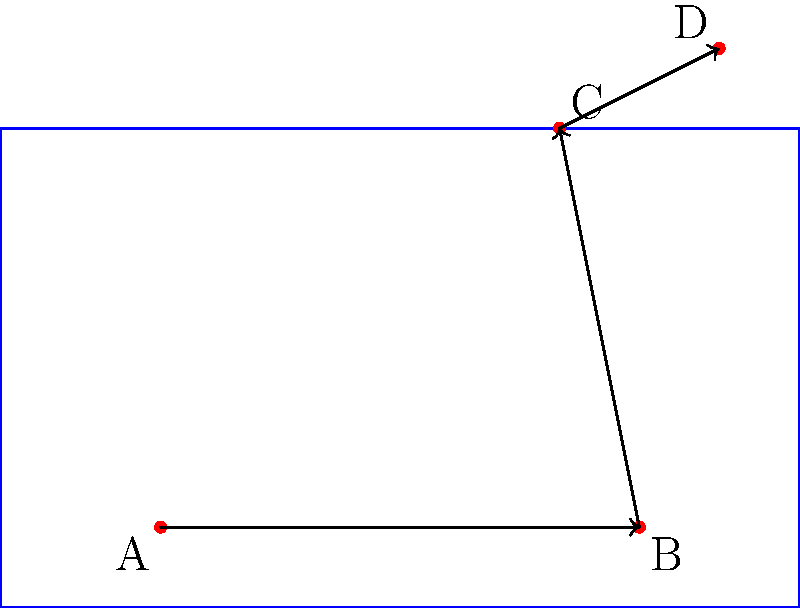In your auto parts store, you need to rearrange a specific part in your storage rack. The part starts at point A(2,1) and undergoes the following transformations:
1. Reflection across the vertical line x=5
2. 90° clockwise rotation around the point (5,3)
3. Translation by the vector (2,1)

What are the final coordinates of the auto part after these transformations? Let's follow the transformations step by step:

1. Reflection across x=5:
   - The x-coordinate changes from 2 to 8 (as 5 + (5-2) = 8)
   - The y-coordinate remains 1
   - New position: B(8,1)

2. 90° clockwise rotation around (5,3):
   - We can use the rotation formula:
     $x' = (x-a)\cos\theta - (y-b)\sin\theta + a$
     $y' = (x-a)\sin\theta + (y-b)\cos\theta + b$
     where (a,b) is the center of rotation (5,3), and $\theta = -90°$ (clockwise)
   - Substituting:
     $x' = (8-5)\cos(-90°) - (1-3)\sin(-90°) + 5 = 7$
     $y' = (8-5)\sin(-90°) + (1-3)\cos(-90°) + 3 = 5$
   - New position: C(7,5)

3. Translation by vector (2,1):
   - Add 2 to x-coordinate and 1 to y-coordinate
   - Final position: D(9,6)

Therefore, the final coordinates of the auto part are (9,6).
Answer: (9,6) 